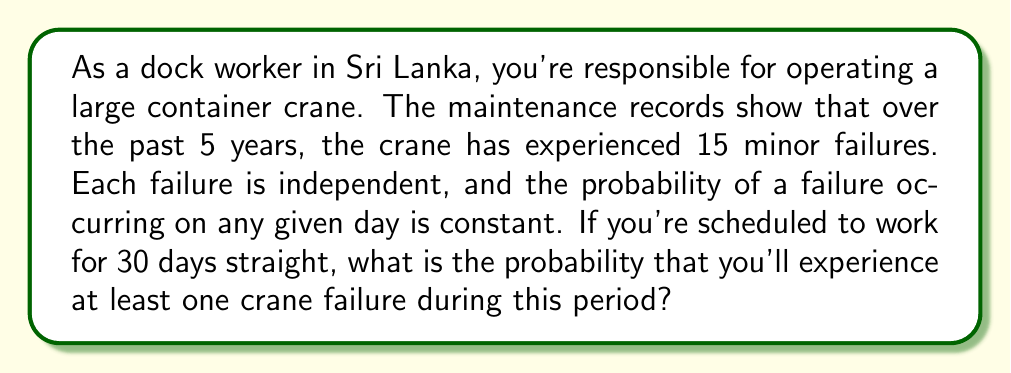Show me your answer to this math problem. Let's approach this step-by-step:

1) First, we need to calculate the daily probability of a failure. We have:
   - 15 failures over 5 years
   - 1 year ≈ 365 days
   - 5 years = 5 × 365 = 1825 days

   Daily probability of failure = $\frac{15}{1825} \approx 0.00822$

2) Now, we want to find the probability of at least one failure in 30 days. It's often easier to calculate the probability of no failures and then subtract from 1.

3) The probability of no failure on a single day is:
   $1 - 0.00822 = 0.99178$

4) For no failures to occur over 30 days, we need this to happen 30 times in a row. The probability is:
   $(0.99178)^{30} \approx 0.78137$

5) Therefore, the probability of at least one failure in 30 days is:
   $1 - 0.78137 = 0.21863$

This can be expressed using the binomial probability formula:

$$P(\text{at least one failure}) = 1 - P(\text{no failures})$$
$$= 1 - (1-p)^n$$

Where $p$ is the daily probability of failure (0.00822) and $n$ is the number of days (30).
Answer: The probability of experiencing at least one crane failure during the 30-day period is approximately 0.21863 or 21.86%. 